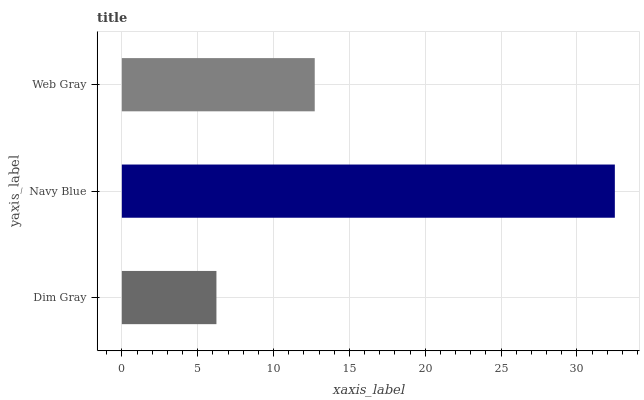Is Dim Gray the minimum?
Answer yes or no. Yes. Is Navy Blue the maximum?
Answer yes or no. Yes. Is Web Gray the minimum?
Answer yes or no. No. Is Web Gray the maximum?
Answer yes or no. No. Is Navy Blue greater than Web Gray?
Answer yes or no. Yes. Is Web Gray less than Navy Blue?
Answer yes or no. Yes. Is Web Gray greater than Navy Blue?
Answer yes or no. No. Is Navy Blue less than Web Gray?
Answer yes or no. No. Is Web Gray the high median?
Answer yes or no. Yes. Is Web Gray the low median?
Answer yes or no. Yes. Is Dim Gray the high median?
Answer yes or no. No. Is Dim Gray the low median?
Answer yes or no. No. 